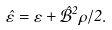Convert formula to latex. <formula><loc_0><loc_0><loc_500><loc_500>\hat { \varepsilon } = \varepsilon + \hat { \mathcal { B } } ^ { 2 } \rho / 2 .</formula> 